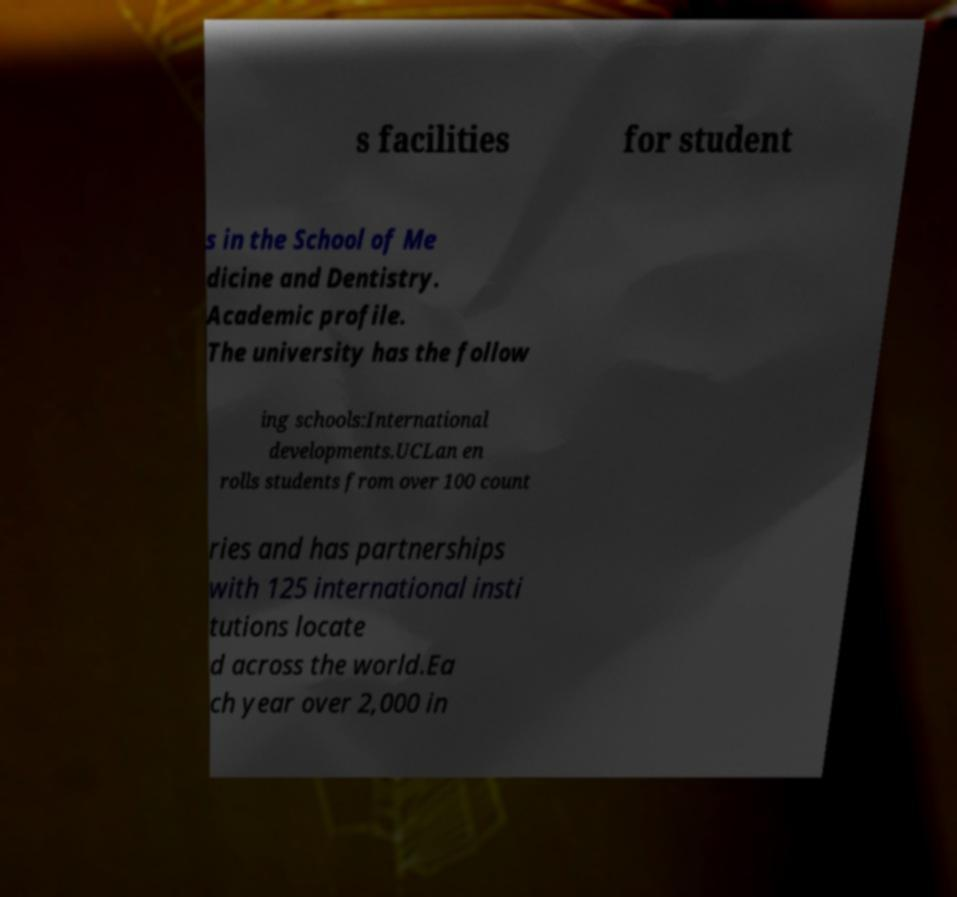For documentation purposes, I need the text within this image transcribed. Could you provide that? s facilities for student s in the School of Me dicine and Dentistry. Academic profile. The university has the follow ing schools:International developments.UCLan en rolls students from over 100 count ries and has partnerships with 125 international insti tutions locate d across the world.Ea ch year over 2,000 in 